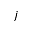<formula> <loc_0><loc_0><loc_500><loc_500>j</formula> 